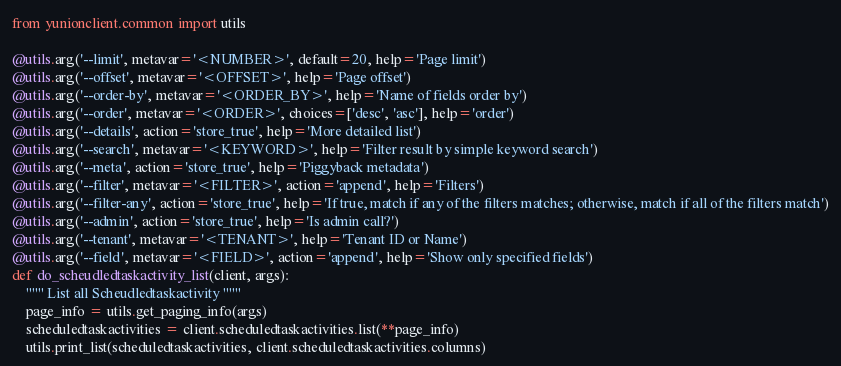<code> <loc_0><loc_0><loc_500><loc_500><_Python_>from yunionclient.common import utils

@utils.arg('--limit', metavar='<NUMBER>', default=20, help='Page limit')
@utils.arg('--offset', metavar='<OFFSET>', help='Page offset')
@utils.arg('--order-by', metavar='<ORDER_BY>', help='Name of fields order by')
@utils.arg('--order', metavar='<ORDER>', choices=['desc', 'asc'], help='order')
@utils.arg('--details', action='store_true', help='More detailed list')
@utils.arg('--search', metavar='<KEYWORD>', help='Filter result by simple keyword search')
@utils.arg('--meta', action='store_true', help='Piggyback metadata')
@utils.arg('--filter', metavar='<FILTER>', action='append', help='Filters')
@utils.arg('--filter-any', action='store_true', help='If true, match if any of the filters matches; otherwise, match if all of the filters match')
@utils.arg('--admin', action='store_true', help='Is admin call?')
@utils.arg('--tenant', metavar='<TENANT>', help='Tenant ID or Name')
@utils.arg('--field', metavar='<FIELD>', action='append', help='Show only specified fields')
def do_scheudledtaskactivity_list(client, args):
    """ List all Scheudledtaskactivity """
    page_info = utils.get_paging_info(args)
    scheduledtaskactivities = client.scheduledtaskactivities.list(**page_info)
    utils.print_list(scheduledtaskactivities, client.scheduledtaskactivities.columns)</code> 